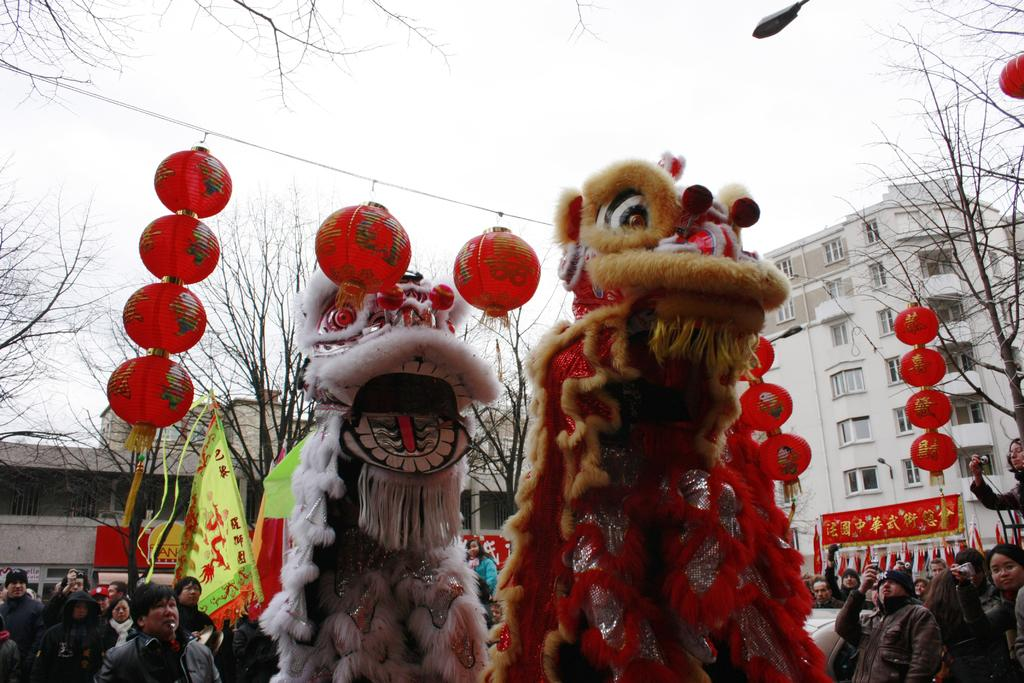What type of objects can be seen in the image? There are puppets in the image. What is hanging from the hanger in the image? There are lanterns placed on a hanger in the image. What is located at the bottom of the image? There is a crowd at the bottom of the image. What type of structures are present in the image? There are boards and buildings in the image. What type of vegetation can be seen in the image? There are trees in the image. What part of the natural environment is visible in the image? The sky is visible in the image. What type of light source is present in the image? There is a light in the image. Can you tell me how many boots are visible in the image? There are no boots present in the image. What type of pencil can be seen being used by the puppets in the image? There are no pencils present in the image, and the puppets are not shown using any writing instruments. 